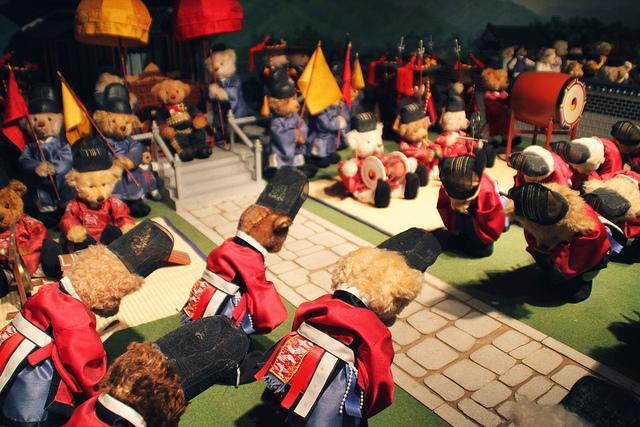Is a small group of people coming down this road seeking the Wizard of OZ?
Short answer required. No. What is shown here?
Give a very brief answer. Bears. What animal is shown?
Keep it brief. Bear. 